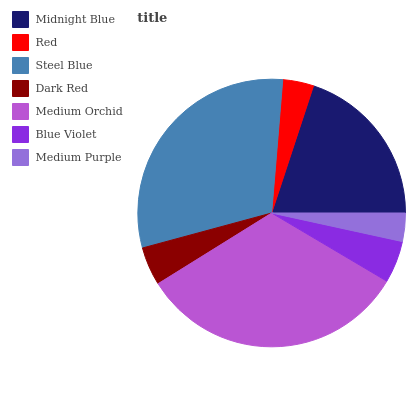Is Medium Purple the minimum?
Answer yes or no. Yes. Is Medium Orchid the maximum?
Answer yes or no. Yes. Is Red the minimum?
Answer yes or no. No. Is Red the maximum?
Answer yes or no. No. Is Midnight Blue greater than Red?
Answer yes or no. Yes. Is Red less than Midnight Blue?
Answer yes or no. Yes. Is Red greater than Midnight Blue?
Answer yes or no. No. Is Midnight Blue less than Red?
Answer yes or no. No. Is Blue Violet the high median?
Answer yes or no. Yes. Is Blue Violet the low median?
Answer yes or no. Yes. Is Medium Purple the high median?
Answer yes or no. No. Is Medium Purple the low median?
Answer yes or no. No. 